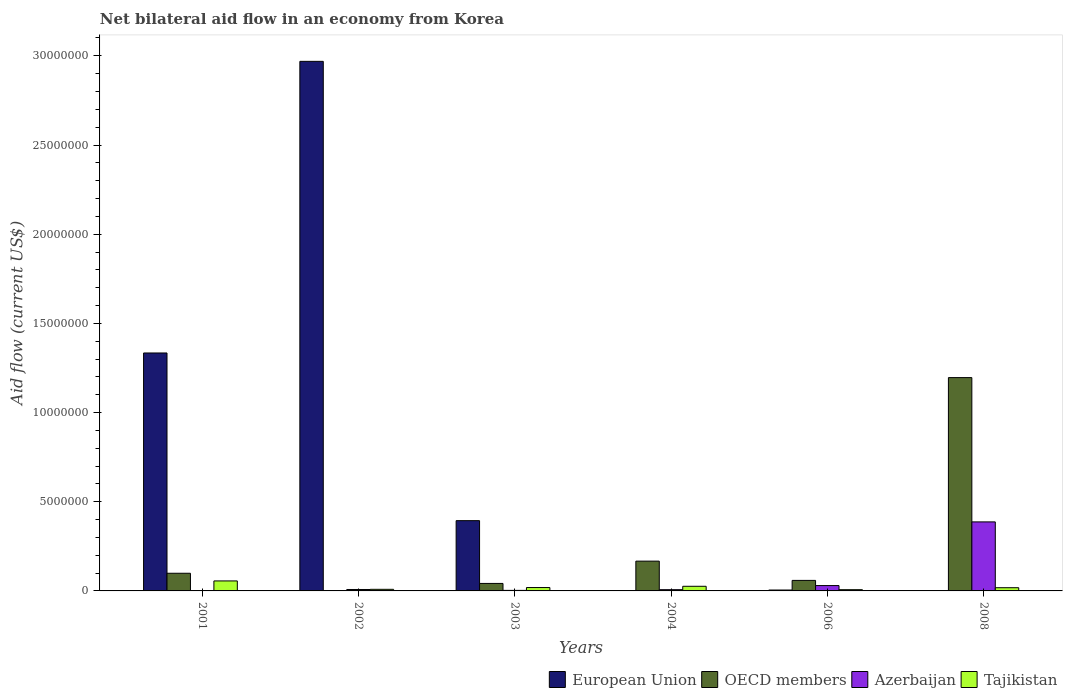How many groups of bars are there?
Your response must be concise. 6. Are the number of bars per tick equal to the number of legend labels?
Give a very brief answer. No. Are the number of bars on each tick of the X-axis equal?
Offer a very short reply. No. How many bars are there on the 6th tick from the left?
Give a very brief answer. 3. What is the label of the 2nd group of bars from the left?
Provide a succinct answer. 2002. In how many cases, is the number of bars for a given year not equal to the number of legend labels?
Your answer should be very brief. 3. Across all years, what is the maximum net bilateral aid flow in Azerbaijan?
Give a very brief answer. 3.87e+06. In which year was the net bilateral aid flow in Tajikistan maximum?
Provide a short and direct response. 2001. What is the total net bilateral aid flow in Azerbaijan in the graph?
Provide a succinct answer. 4.37e+06. What is the difference between the net bilateral aid flow in Azerbaijan in 2002 and the net bilateral aid flow in Tajikistan in 2004?
Your answer should be very brief. -1.80e+05. What is the average net bilateral aid flow in OECD members per year?
Provide a succinct answer. 2.60e+06. In the year 2003, what is the difference between the net bilateral aid flow in Azerbaijan and net bilateral aid flow in European Union?
Give a very brief answer. -3.91e+06. What is the ratio of the net bilateral aid flow in Tajikistan in 2002 to that in 2003?
Make the answer very short. 0.47. What is the difference between the highest and the second highest net bilateral aid flow in OECD members?
Make the answer very short. 1.03e+07. What is the difference between the highest and the lowest net bilateral aid flow in Azerbaijan?
Your answer should be very brief. 3.85e+06. In how many years, is the net bilateral aid flow in European Union greater than the average net bilateral aid flow in European Union taken over all years?
Provide a short and direct response. 2. Is the sum of the net bilateral aid flow in Azerbaijan in 2002 and 2008 greater than the maximum net bilateral aid flow in OECD members across all years?
Your answer should be compact. No. How many bars are there?
Offer a very short reply. 21. What is the difference between two consecutive major ticks on the Y-axis?
Offer a terse response. 5.00e+06. Are the values on the major ticks of Y-axis written in scientific E-notation?
Give a very brief answer. No. Does the graph contain any zero values?
Your answer should be very brief. Yes. Does the graph contain grids?
Keep it short and to the point. No. How many legend labels are there?
Offer a terse response. 4. How are the legend labels stacked?
Give a very brief answer. Horizontal. What is the title of the graph?
Make the answer very short. Net bilateral aid flow in an economy from Korea. What is the label or title of the X-axis?
Make the answer very short. Years. What is the Aid flow (current US$) in European Union in 2001?
Ensure brevity in your answer.  1.33e+07. What is the Aid flow (current US$) of OECD members in 2001?
Provide a succinct answer. 9.90e+05. What is the Aid flow (current US$) of Tajikistan in 2001?
Make the answer very short. 5.60e+05. What is the Aid flow (current US$) of European Union in 2002?
Offer a terse response. 2.97e+07. What is the Aid flow (current US$) of OECD members in 2002?
Offer a very short reply. 0. What is the Aid flow (current US$) of Tajikistan in 2002?
Make the answer very short. 9.00e+04. What is the Aid flow (current US$) of European Union in 2003?
Offer a terse response. 3.94e+06. What is the Aid flow (current US$) in OECD members in 2003?
Ensure brevity in your answer.  4.20e+05. What is the Aid flow (current US$) in European Union in 2004?
Your response must be concise. 0. What is the Aid flow (current US$) of OECD members in 2004?
Provide a short and direct response. 1.67e+06. What is the Aid flow (current US$) of Azerbaijan in 2004?
Offer a terse response. 7.00e+04. What is the Aid flow (current US$) in European Union in 2006?
Your answer should be very brief. 5.00e+04. What is the Aid flow (current US$) in OECD members in 2006?
Offer a terse response. 5.90e+05. What is the Aid flow (current US$) in Tajikistan in 2006?
Your answer should be very brief. 7.00e+04. What is the Aid flow (current US$) in European Union in 2008?
Offer a very short reply. 0. What is the Aid flow (current US$) of OECD members in 2008?
Provide a short and direct response. 1.20e+07. What is the Aid flow (current US$) in Azerbaijan in 2008?
Provide a succinct answer. 3.87e+06. Across all years, what is the maximum Aid flow (current US$) in European Union?
Give a very brief answer. 2.97e+07. Across all years, what is the maximum Aid flow (current US$) in OECD members?
Give a very brief answer. 1.20e+07. Across all years, what is the maximum Aid flow (current US$) in Azerbaijan?
Provide a short and direct response. 3.87e+06. Across all years, what is the maximum Aid flow (current US$) in Tajikistan?
Ensure brevity in your answer.  5.60e+05. Across all years, what is the minimum Aid flow (current US$) in OECD members?
Give a very brief answer. 0. Across all years, what is the minimum Aid flow (current US$) in Azerbaijan?
Give a very brief answer. 2.00e+04. What is the total Aid flow (current US$) of European Union in the graph?
Offer a very short reply. 4.70e+07. What is the total Aid flow (current US$) of OECD members in the graph?
Offer a very short reply. 1.56e+07. What is the total Aid flow (current US$) of Azerbaijan in the graph?
Offer a very short reply. 4.37e+06. What is the total Aid flow (current US$) in Tajikistan in the graph?
Ensure brevity in your answer.  1.35e+06. What is the difference between the Aid flow (current US$) in European Union in 2001 and that in 2002?
Offer a terse response. -1.64e+07. What is the difference between the Aid flow (current US$) of European Union in 2001 and that in 2003?
Ensure brevity in your answer.  9.40e+06. What is the difference between the Aid flow (current US$) in OECD members in 2001 and that in 2003?
Give a very brief answer. 5.70e+05. What is the difference between the Aid flow (current US$) in Azerbaijan in 2001 and that in 2003?
Make the answer very short. -10000. What is the difference between the Aid flow (current US$) in OECD members in 2001 and that in 2004?
Keep it short and to the point. -6.80e+05. What is the difference between the Aid flow (current US$) of Azerbaijan in 2001 and that in 2004?
Your answer should be very brief. -5.00e+04. What is the difference between the Aid flow (current US$) of Tajikistan in 2001 and that in 2004?
Provide a short and direct response. 3.00e+05. What is the difference between the Aid flow (current US$) in European Union in 2001 and that in 2006?
Offer a terse response. 1.33e+07. What is the difference between the Aid flow (current US$) in OECD members in 2001 and that in 2006?
Offer a very short reply. 4.00e+05. What is the difference between the Aid flow (current US$) in Azerbaijan in 2001 and that in 2006?
Your answer should be very brief. -2.80e+05. What is the difference between the Aid flow (current US$) of Tajikistan in 2001 and that in 2006?
Ensure brevity in your answer.  4.90e+05. What is the difference between the Aid flow (current US$) of OECD members in 2001 and that in 2008?
Your answer should be very brief. -1.10e+07. What is the difference between the Aid flow (current US$) of Azerbaijan in 2001 and that in 2008?
Provide a succinct answer. -3.85e+06. What is the difference between the Aid flow (current US$) in Tajikistan in 2001 and that in 2008?
Ensure brevity in your answer.  3.80e+05. What is the difference between the Aid flow (current US$) in European Union in 2002 and that in 2003?
Your answer should be very brief. 2.58e+07. What is the difference between the Aid flow (current US$) in Azerbaijan in 2002 and that in 2003?
Offer a terse response. 5.00e+04. What is the difference between the Aid flow (current US$) in Tajikistan in 2002 and that in 2003?
Your answer should be very brief. -1.00e+05. What is the difference between the Aid flow (current US$) of Azerbaijan in 2002 and that in 2004?
Keep it short and to the point. 10000. What is the difference between the Aid flow (current US$) in European Union in 2002 and that in 2006?
Your answer should be very brief. 2.96e+07. What is the difference between the Aid flow (current US$) of Azerbaijan in 2002 and that in 2008?
Keep it short and to the point. -3.79e+06. What is the difference between the Aid flow (current US$) in Tajikistan in 2002 and that in 2008?
Provide a succinct answer. -9.00e+04. What is the difference between the Aid flow (current US$) of OECD members in 2003 and that in 2004?
Make the answer very short. -1.25e+06. What is the difference between the Aid flow (current US$) of Tajikistan in 2003 and that in 2004?
Provide a short and direct response. -7.00e+04. What is the difference between the Aid flow (current US$) in European Union in 2003 and that in 2006?
Offer a terse response. 3.89e+06. What is the difference between the Aid flow (current US$) in Azerbaijan in 2003 and that in 2006?
Your answer should be compact. -2.70e+05. What is the difference between the Aid flow (current US$) of OECD members in 2003 and that in 2008?
Give a very brief answer. -1.15e+07. What is the difference between the Aid flow (current US$) of Azerbaijan in 2003 and that in 2008?
Keep it short and to the point. -3.84e+06. What is the difference between the Aid flow (current US$) in Tajikistan in 2003 and that in 2008?
Provide a succinct answer. 10000. What is the difference between the Aid flow (current US$) in OECD members in 2004 and that in 2006?
Give a very brief answer. 1.08e+06. What is the difference between the Aid flow (current US$) in Azerbaijan in 2004 and that in 2006?
Keep it short and to the point. -2.30e+05. What is the difference between the Aid flow (current US$) in OECD members in 2004 and that in 2008?
Keep it short and to the point. -1.03e+07. What is the difference between the Aid flow (current US$) in Azerbaijan in 2004 and that in 2008?
Provide a short and direct response. -3.80e+06. What is the difference between the Aid flow (current US$) of Tajikistan in 2004 and that in 2008?
Keep it short and to the point. 8.00e+04. What is the difference between the Aid flow (current US$) in OECD members in 2006 and that in 2008?
Your answer should be very brief. -1.14e+07. What is the difference between the Aid flow (current US$) in Azerbaijan in 2006 and that in 2008?
Offer a terse response. -3.57e+06. What is the difference between the Aid flow (current US$) of Tajikistan in 2006 and that in 2008?
Keep it short and to the point. -1.10e+05. What is the difference between the Aid flow (current US$) of European Union in 2001 and the Aid flow (current US$) of Azerbaijan in 2002?
Make the answer very short. 1.33e+07. What is the difference between the Aid flow (current US$) of European Union in 2001 and the Aid flow (current US$) of Tajikistan in 2002?
Give a very brief answer. 1.32e+07. What is the difference between the Aid flow (current US$) in OECD members in 2001 and the Aid flow (current US$) in Azerbaijan in 2002?
Give a very brief answer. 9.10e+05. What is the difference between the Aid flow (current US$) in Azerbaijan in 2001 and the Aid flow (current US$) in Tajikistan in 2002?
Your response must be concise. -7.00e+04. What is the difference between the Aid flow (current US$) in European Union in 2001 and the Aid flow (current US$) in OECD members in 2003?
Your answer should be very brief. 1.29e+07. What is the difference between the Aid flow (current US$) of European Union in 2001 and the Aid flow (current US$) of Azerbaijan in 2003?
Make the answer very short. 1.33e+07. What is the difference between the Aid flow (current US$) of European Union in 2001 and the Aid flow (current US$) of Tajikistan in 2003?
Keep it short and to the point. 1.32e+07. What is the difference between the Aid flow (current US$) in OECD members in 2001 and the Aid flow (current US$) in Azerbaijan in 2003?
Keep it short and to the point. 9.60e+05. What is the difference between the Aid flow (current US$) in OECD members in 2001 and the Aid flow (current US$) in Tajikistan in 2003?
Give a very brief answer. 8.00e+05. What is the difference between the Aid flow (current US$) of European Union in 2001 and the Aid flow (current US$) of OECD members in 2004?
Make the answer very short. 1.17e+07. What is the difference between the Aid flow (current US$) of European Union in 2001 and the Aid flow (current US$) of Azerbaijan in 2004?
Provide a succinct answer. 1.33e+07. What is the difference between the Aid flow (current US$) in European Union in 2001 and the Aid flow (current US$) in Tajikistan in 2004?
Give a very brief answer. 1.31e+07. What is the difference between the Aid flow (current US$) of OECD members in 2001 and the Aid flow (current US$) of Azerbaijan in 2004?
Offer a very short reply. 9.20e+05. What is the difference between the Aid flow (current US$) of OECD members in 2001 and the Aid flow (current US$) of Tajikistan in 2004?
Offer a very short reply. 7.30e+05. What is the difference between the Aid flow (current US$) of Azerbaijan in 2001 and the Aid flow (current US$) of Tajikistan in 2004?
Offer a very short reply. -2.40e+05. What is the difference between the Aid flow (current US$) in European Union in 2001 and the Aid flow (current US$) in OECD members in 2006?
Offer a very short reply. 1.28e+07. What is the difference between the Aid flow (current US$) in European Union in 2001 and the Aid flow (current US$) in Azerbaijan in 2006?
Provide a short and direct response. 1.30e+07. What is the difference between the Aid flow (current US$) in European Union in 2001 and the Aid flow (current US$) in Tajikistan in 2006?
Offer a terse response. 1.33e+07. What is the difference between the Aid flow (current US$) of OECD members in 2001 and the Aid flow (current US$) of Azerbaijan in 2006?
Make the answer very short. 6.90e+05. What is the difference between the Aid flow (current US$) of OECD members in 2001 and the Aid flow (current US$) of Tajikistan in 2006?
Keep it short and to the point. 9.20e+05. What is the difference between the Aid flow (current US$) in Azerbaijan in 2001 and the Aid flow (current US$) in Tajikistan in 2006?
Ensure brevity in your answer.  -5.00e+04. What is the difference between the Aid flow (current US$) in European Union in 2001 and the Aid flow (current US$) in OECD members in 2008?
Your answer should be very brief. 1.38e+06. What is the difference between the Aid flow (current US$) of European Union in 2001 and the Aid flow (current US$) of Azerbaijan in 2008?
Make the answer very short. 9.47e+06. What is the difference between the Aid flow (current US$) in European Union in 2001 and the Aid flow (current US$) in Tajikistan in 2008?
Offer a terse response. 1.32e+07. What is the difference between the Aid flow (current US$) in OECD members in 2001 and the Aid flow (current US$) in Azerbaijan in 2008?
Ensure brevity in your answer.  -2.88e+06. What is the difference between the Aid flow (current US$) of OECD members in 2001 and the Aid flow (current US$) of Tajikistan in 2008?
Offer a terse response. 8.10e+05. What is the difference between the Aid flow (current US$) of European Union in 2002 and the Aid flow (current US$) of OECD members in 2003?
Offer a very short reply. 2.93e+07. What is the difference between the Aid flow (current US$) of European Union in 2002 and the Aid flow (current US$) of Azerbaijan in 2003?
Provide a succinct answer. 2.97e+07. What is the difference between the Aid flow (current US$) of European Union in 2002 and the Aid flow (current US$) of Tajikistan in 2003?
Your answer should be very brief. 2.95e+07. What is the difference between the Aid flow (current US$) in European Union in 2002 and the Aid flow (current US$) in OECD members in 2004?
Your response must be concise. 2.80e+07. What is the difference between the Aid flow (current US$) in European Union in 2002 and the Aid flow (current US$) in Azerbaijan in 2004?
Make the answer very short. 2.96e+07. What is the difference between the Aid flow (current US$) in European Union in 2002 and the Aid flow (current US$) in Tajikistan in 2004?
Provide a succinct answer. 2.94e+07. What is the difference between the Aid flow (current US$) in European Union in 2002 and the Aid flow (current US$) in OECD members in 2006?
Your answer should be compact. 2.91e+07. What is the difference between the Aid flow (current US$) in European Union in 2002 and the Aid flow (current US$) in Azerbaijan in 2006?
Offer a very short reply. 2.94e+07. What is the difference between the Aid flow (current US$) in European Union in 2002 and the Aid flow (current US$) in Tajikistan in 2006?
Your answer should be very brief. 2.96e+07. What is the difference between the Aid flow (current US$) in Azerbaijan in 2002 and the Aid flow (current US$) in Tajikistan in 2006?
Offer a very short reply. 10000. What is the difference between the Aid flow (current US$) in European Union in 2002 and the Aid flow (current US$) in OECD members in 2008?
Your answer should be compact. 1.77e+07. What is the difference between the Aid flow (current US$) in European Union in 2002 and the Aid flow (current US$) in Azerbaijan in 2008?
Offer a terse response. 2.58e+07. What is the difference between the Aid flow (current US$) in European Union in 2002 and the Aid flow (current US$) in Tajikistan in 2008?
Your answer should be very brief. 2.95e+07. What is the difference between the Aid flow (current US$) of Azerbaijan in 2002 and the Aid flow (current US$) of Tajikistan in 2008?
Give a very brief answer. -1.00e+05. What is the difference between the Aid flow (current US$) in European Union in 2003 and the Aid flow (current US$) in OECD members in 2004?
Your response must be concise. 2.27e+06. What is the difference between the Aid flow (current US$) in European Union in 2003 and the Aid flow (current US$) in Azerbaijan in 2004?
Provide a succinct answer. 3.87e+06. What is the difference between the Aid flow (current US$) in European Union in 2003 and the Aid flow (current US$) in Tajikistan in 2004?
Keep it short and to the point. 3.68e+06. What is the difference between the Aid flow (current US$) in Azerbaijan in 2003 and the Aid flow (current US$) in Tajikistan in 2004?
Your answer should be very brief. -2.30e+05. What is the difference between the Aid flow (current US$) of European Union in 2003 and the Aid flow (current US$) of OECD members in 2006?
Make the answer very short. 3.35e+06. What is the difference between the Aid flow (current US$) of European Union in 2003 and the Aid flow (current US$) of Azerbaijan in 2006?
Make the answer very short. 3.64e+06. What is the difference between the Aid flow (current US$) in European Union in 2003 and the Aid flow (current US$) in Tajikistan in 2006?
Keep it short and to the point. 3.87e+06. What is the difference between the Aid flow (current US$) in OECD members in 2003 and the Aid flow (current US$) in Tajikistan in 2006?
Give a very brief answer. 3.50e+05. What is the difference between the Aid flow (current US$) of Azerbaijan in 2003 and the Aid flow (current US$) of Tajikistan in 2006?
Ensure brevity in your answer.  -4.00e+04. What is the difference between the Aid flow (current US$) of European Union in 2003 and the Aid flow (current US$) of OECD members in 2008?
Give a very brief answer. -8.02e+06. What is the difference between the Aid flow (current US$) of European Union in 2003 and the Aid flow (current US$) of Azerbaijan in 2008?
Your answer should be compact. 7.00e+04. What is the difference between the Aid flow (current US$) in European Union in 2003 and the Aid flow (current US$) in Tajikistan in 2008?
Provide a succinct answer. 3.76e+06. What is the difference between the Aid flow (current US$) of OECD members in 2003 and the Aid flow (current US$) of Azerbaijan in 2008?
Your response must be concise. -3.45e+06. What is the difference between the Aid flow (current US$) in OECD members in 2003 and the Aid flow (current US$) in Tajikistan in 2008?
Offer a terse response. 2.40e+05. What is the difference between the Aid flow (current US$) in Azerbaijan in 2003 and the Aid flow (current US$) in Tajikistan in 2008?
Offer a very short reply. -1.50e+05. What is the difference between the Aid flow (current US$) in OECD members in 2004 and the Aid flow (current US$) in Azerbaijan in 2006?
Ensure brevity in your answer.  1.37e+06. What is the difference between the Aid flow (current US$) of OECD members in 2004 and the Aid flow (current US$) of Tajikistan in 2006?
Your answer should be very brief. 1.60e+06. What is the difference between the Aid flow (current US$) in OECD members in 2004 and the Aid flow (current US$) in Azerbaijan in 2008?
Your response must be concise. -2.20e+06. What is the difference between the Aid flow (current US$) of OECD members in 2004 and the Aid flow (current US$) of Tajikistan in 2008?
Make the answer very short. 1.49e+06. What is the difference between the Aid flow (current US$) in European Union in 2006 and the Aid flow (current US$) in OECD members in 2008?
Provide a succinct answer. -1.19e+07. What is the difference between the Aid flow (current US$) of European Union in 2006 and the Aid flow (current US$) of Azerbaijan in 2008?
Make the answer very short. -3.82e+06. What is the difference between the Aid flow (current US$) of European Union in 2006 and the Aid flow (current US$) of Tajikistan in 2008?
Your answer should be very brief. -1.30e+05. What is the difference between the Aid flow (current US$) in OECD members in 2006 and the Aid flow (current US$) in Azerbaijan in 2008?
Keep it short and to the point. -3.28e+06. What is the difference between the Aid flow (current US$) of Azerbaijan in 2006 and the Aid flow (current US$) of Tajikistan in 2008?
Provide a short and direct response. 1.20e+05. What is the average Aid flow (current US$) of European Union per year?
Your answer should be compact. 7.84e+06. What is the average Aid flow (current US$) of OECD members per year?
Your answer should be very brief. 2.60e+06. What is the average Aid flow (current US$) in Azerbaijan per year?
Your response must be concise. 7.28e+05. What is the average Aid flow (current US$) in Tajikistan per year?
Your response must be concise. 2.25e+05. In the year 2001, what is the difference between the Aid flow (current US$) of European Union and Aid flow (current US$) of OECD members?
Provide a short and direct response. 1.24e+07. In the year 2001, what is the difference between the Aid flow (current US$) in European Union and Aid flow (current US$) in Azerbaijan?
Ensure brevity in your answer.  1.33e+07. In the year 2001, what is the difference between the Aid flow (current US$) in European Union and Aid flow (current US$) in Tajikistan?
Provide a short and direct response. 1.28e+07. In the year 2001, what is the difference between the Aid flow (current US$) of OECD members and Aid flow (current US$) of Azerbaijan?
Offer a very short reply. 9.70e+05. In the year 2001, what is the difference between the Aid flow (current US$) in Azerbaijan and Aid flow (current US$) in Tajikistan?
Offer a very short reply. -5.40e+05. In the year 2002, what is the difference between the Aid flow (current US$) in European Union and Aid flow (current US$) in Azerbaijan?
Your answer should be very brief. 2.96e+07. In the year 2002, what is the difference between the Aid flow (current US$) of European Union and Aid flow (current US$) of Tajikistan?
Make the answer very short. 2.96e+07. In the year 2003, what is the difference between the Aid flow (current US$) of European Union and Aid flow (current US$) of OECD members?
Your answer should be compact. 3.52e+06. In the year 2003, what is the difference between the Aid flow (current US$) in European Union and Aid flow (current US$) in Azerbaijan?
Ensure brevity in your answer.  3.91e+06. In the year 2003, what is the difference between the Aid flow (current US$) in European Union and Aid flow (current US$) in Tajikistan?
Offer a terse response. 3.75e+06. In the year 2003, what is the difference between the Aid flow (current US$) of OECD members and Aid flow (current US$) of Azerbaijan?
Offer a very short reply. 3.90e+05. In the year 2003, what is the difference between the Aid flow (current US$) of Azerbaijan and Aid flow (current US$) of Tajikistan?
Ensure brevity in your answer.  -1.60e+05. In the year 2004, what is the difference between the Aid flow (current US$) of OECD members and Aid flow (current US$) of Azerbaijan?
Make the answer very short. 1.60e+06. In the year 2004, what is the difference between the Aid flow (current US$) in OECD members and Aid flow (current US$) in Tajikistan?
Provide a succinct answer. 1.41e+06. In the year 2006, what is the difference between the Aid flow (current US$) in European Union and Aid flow (current US$) in OECD members?
Offer a very short reply. -5.40e+05. In the year 2006, what is the difference between the Aid flow (current US$) of European Union and Aid flow (current US$) of Tajikistan?
Offer a very short reply. -2.00e+04. In the year 2006, what is the difference between the Aid flow (current US$) in OECD members and Aid flow (current US$) in Tajikistan?
Provide a short and direct response. 5.20e+05. In the year 2008, what is the difference between the Aid flow (current US$) of OECD members and Aid flow (current US$) of Azerbaijan?
Offer a very short reply. 8.09e+06. In the year 2008, what is the difference between the Aid flow (current US$) of OECD members and Aid flow (current US$) of Tajikistan?
Your answer should be compact. 1.18e+07. In the year 2008, what is the difference between the Aid flow (current US$) of Azerbaijan and Aid flow (current US$) of Tajikistan?
Offer a very short reply. 3.69e+06. What is the ratio of the Aid flow (current US$) of European Union in 2001 to that in 2002?
Provide a short and direct response. 0.45. What is the ratio of the Aid flow (current US$) in Azerbaijan in 2001 to that in 2002?
Provide a short and direct response. 0.25. What is the ratio of the Aid flow (current US$) in Tajikistan in 2001 to that in 2002?
Provide a short and direct response. 6.22. What is the ratio of the Aid flow (current US$) of European Union in 2001 to that in 2003?
Ensure brevity in your answer.  3.39. What is the ratio of the Aid flow (current US$) of OECD members in 2001 to that in 2003?
Provide a succinct answer. 2.36. What is the ratio of the Aid flow (current US$) of Azerbaijan in 2001 to that in 2003?
Make the answer very short. 0.67. What is the ratio of the Aid flow (current US$) in Tajikistan in 2001 to that in 2003?
Provide a succinct answer. 2.95. What is the ratio of the Aid flow (current US$) in OECD members in 2001 to that in 2004?
Your response must be concise. 0.59. What is the ratio of the Aid flow (current US$) in Azerbaijan in 2001 to that in 2004?
Provide a succinct answer. 0.29. What is the ratio of the Aid flow (current US$) of Tajikistan in 2001 to that in 2004?
Keep it short and to the point. 2.15. What is the ratio of the Aid flow (current US$) of European Union in 2001 to that in 2006?
Make the answer very short. 266.8. What is the ratio of the Aid flow (current US$) in OECD members in 2001 to that in 2006?
Ensure brevity in your answer.  1.68. What is the ratio of the Aid flow (current US$) in Azerbaijan in 2001 to that in 2006?
Give a very brief answer. 0.07. What is the ratio of the Aid flow (current US$) in Tajikistan in 2001 to that in 2006?
Make the answer very short. 8. What is the ratio of the Aid flow (current US$) in OECD members in 2001 to that in 2008?
Make the answer very short. 0.08. What is the ratio of the Aid flow (current US$) of Azerbaijan in 2001 to that in 2008?
Ensure brevity in your answer.  0.01. What is the ratio of the Aid flow (current US$) of Tajikistan in 2001 to that in 2008?
Keep it short and to the point. 3.11. What is the ratio of the Aid flow (current US$) in European Union in 2002 to that in 2003?
Your response must be concise. 7.54. What is the ratio of the Aid flow (current US$) of Azerbaijan in 2002 to that in 2003?
Your answer should be compact. 2.67. What is the ratio of the Aid flow (current US$) in Tajikistan in 2002 to that in 2003?
Your response must be concise. 0.47. What is the ratio of the Aid flow (current US$) of Tajikistan in 2002 to that in 2004?
Your answer should be very brief. 0.35. What is the ratio of the Aid flow (current US$) in European Union in 2002 to that in 2006?
Your response must be concise. 593.8. What is the ratio of the Aid flow (current US$) of Azerbaijan in 2002 to that in 2006?
Your answer should be very brief. 0.27. What is the ratio of the Aid flow (current US$) in Azerbaijan in 2002 to that in 2008?
Make the answer very short. 0.02. What is the ratio of the Aid flow (current US$) in OECD members in 2003 to that in 2004?
Keep it short and to the point. 0.25. What is the ratio of the Aid flow (current US$) in Azerbaijan in 2003 to that in 2004?
Keep it short and to the point. 0.43. What is the ratio of the Aid flow (current US$) in Tajikistan in 2003 to that in 2004?
Keep it short and to the point. 0.73. What is the ratio of the Aid flow (current US$) in European Union in 2003 to that in 2006?
Keep it short and to the point. 78.8. What is the ratio of the Aid flow (current US$) of OECD members in 2003 to that in 2006?
Make the answer very short. 0.71. What is the ratio of the Aid flow (current US$) in Azerbaijan in 2003 to that in 2006?
Offer a terse response. 0.1. What is the ratio of the Aid flow (current US$) of Tajikistan in 2003 to that in 2006?
Ensure brevity in your answer.  2.71. What is the ratio of the Aid flow (current US$) of OECD members in 2003 to that in 2008?
Your answer should be compact. 0.04. What is the ratio of the Aid flow (current US$) of Azerbaijan in 2003 to that in 2008?
Keep it short and to the point. 0.01. What is the ratio of the Aid flow (current US$) of Tajikistan in 2003 to that in 2008?
Keep it short and to the point. 1.06. What is the ratio of the Aid flow (current US$) of OECD members in 2004 to that in 2006?
Provide a succinct answer. 2.83. What is the ratio of the Aid flow (current US$) in Azerbaijan in 2004 to that in 2006?
Your answer should be compact. 0.23. What is the ratio of the Aid flow (current US$) of Tajikistan in 2004 to that in 2006?
Give a very brief answer. 3.71. What is the ratio of the Aid flow (current US$) of OECD members in 2004 to that in 2008?
Keep it short and to the point. 0.14. What is the ratio of the Aid flow (current US$) in Azerbaijan in 2004 to that in 2008?
Make the answer very short. 0.02. What is the ratio of the Aid flow (current US$) of Tajikistan in 2004 to that in 2008?
Keep it short and to the point. 1.44. What is the ratio of the Aid flow (current US$) of OECD members in 2006 to that in 2008?
Offer a terse response. 0.05. What is the ratio of the Aid flow (current US$) in Azerbaijan in 2006 to that in 2008?
Your answer should be compact. 0.08. What is the ratio of the Aid flow (current US$) of Tajikistan in 2006 to that in 2008?
Provide a short and direct response. 0.39. What is the difference between the highest and the second highest Aid flow (current US$) in European Union?
Make the answer very short. 1.64e+07. What is the difference between the highest and the second highest Aid flow (current US$) of OECD members?
Your answer should be compact. 1.03e+07. What is the difference between the highest and the second highest Aid flow (current US$) of Azerbaijan?
Your answer should be compact. 3.57e+06. What is the difference between the highest and the lowest Aid flow (current US$) of European Union?
Ensure brevity in your answer.  2.97e+07. What is the difference between the highest and the lowest Aid flow (current US$) of OECD members?
Offer a very short reply. 1.20e+07. What is the difference between the highest and the lowest Aid flow (current US$) in Azerbaijan?
Provide a short and direct response. 3.85e+06. 